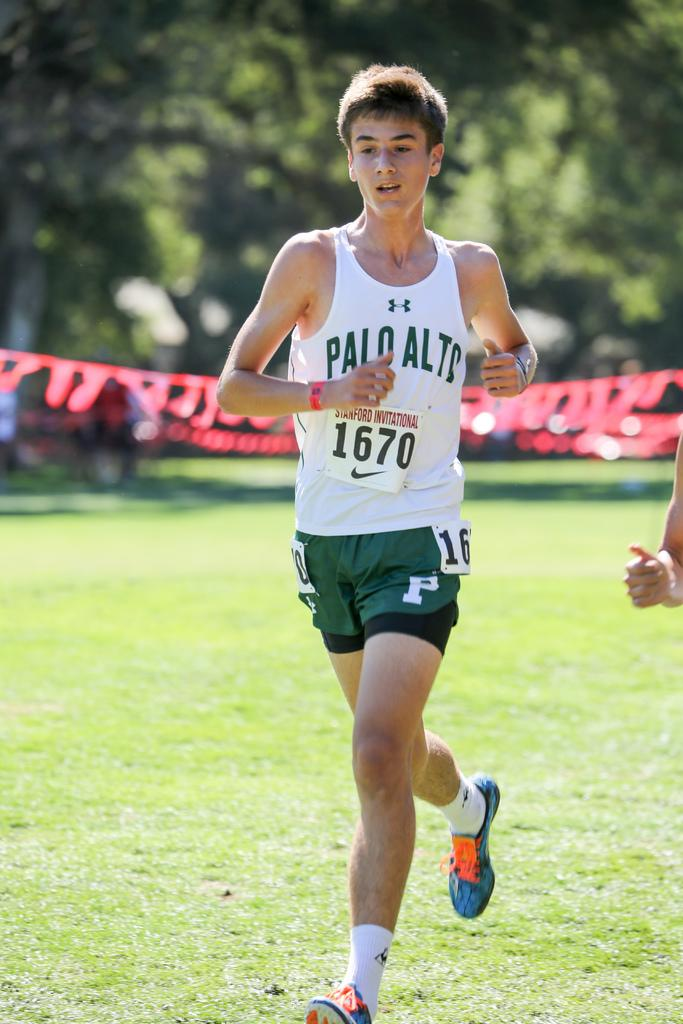Provide a one-sentence caption for the provided image. A young man is running on the track team from Palo Alto. 